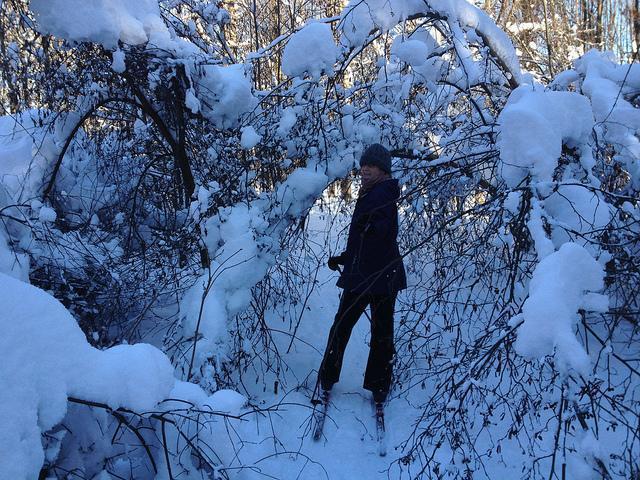How many elephants are in the picture?
Give a very brief answer. 0. 